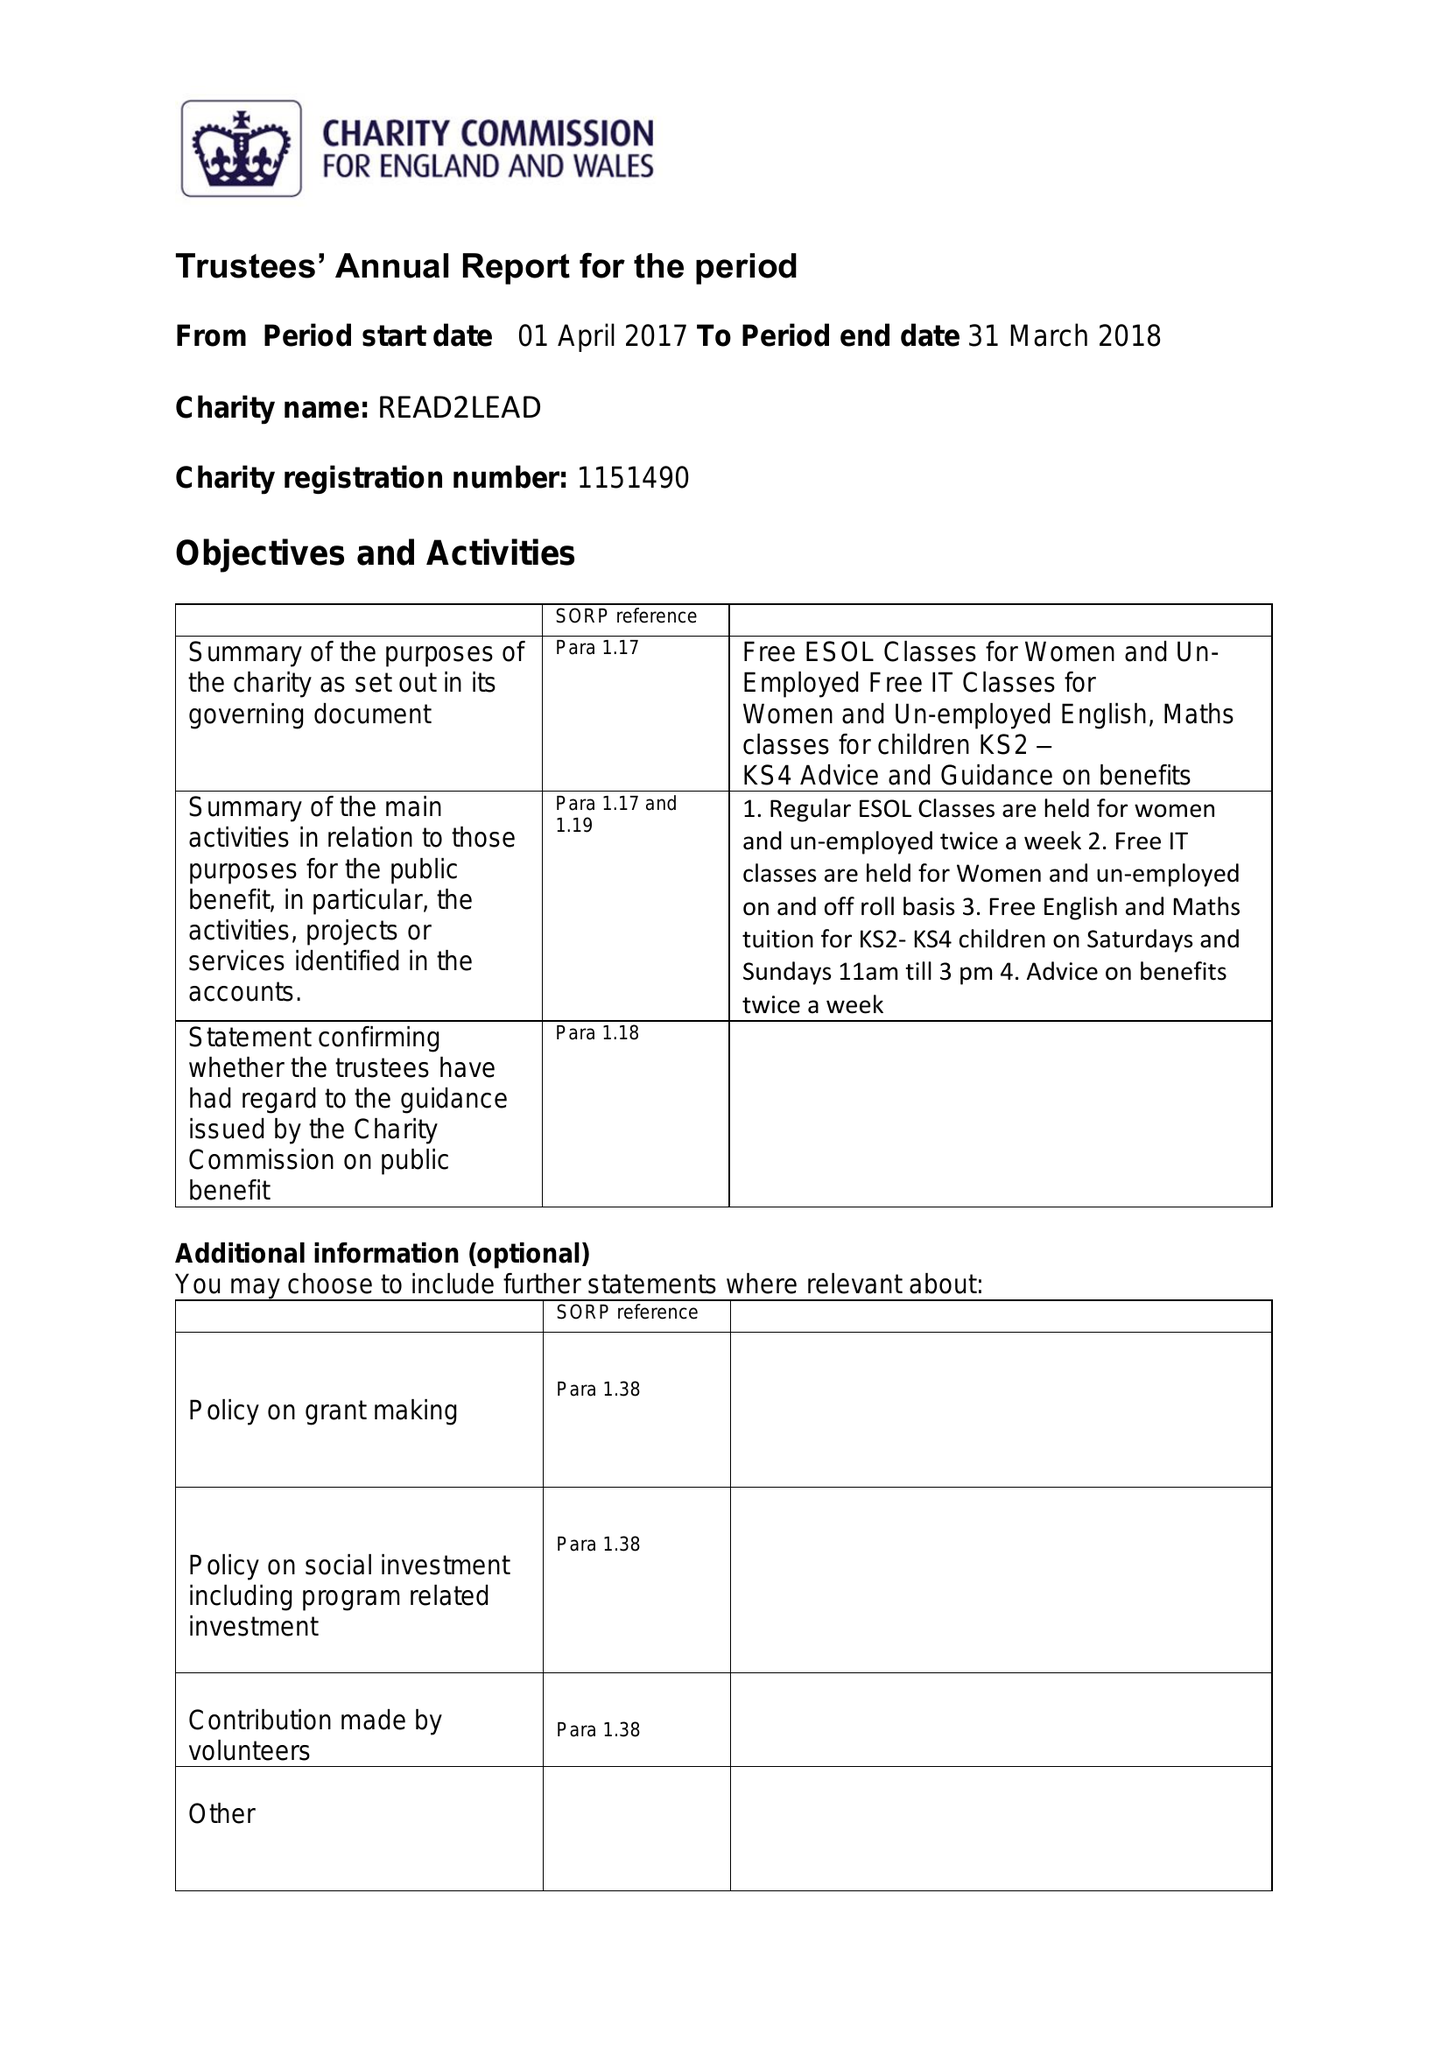What is the value for the income_annually_in_british_pounds?
Answer the question using a single word or phrase. 13059.00 